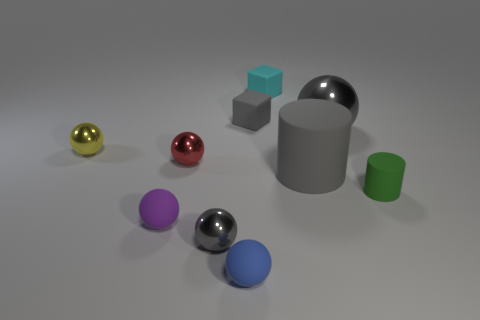Subtract all tiny matte spheres. How many spheres are left? 4 Subtract all red spheres. How many spheres are left? 5 Subtract all brown spheres. Subtract all purple cylinders. How many spheres are left? 6 Subtract all spheres. How many objects are left? 4 Add 8 tiny blue balls. How many tiny blue balls are left? 9 Add 5 big red balls. How many big red balls exist? 5 Subtract 0 green cubes. How many objects are left? 10 Subtract all tiny blue matte balls. Subtract all rubber objects. How many objects are left? 3 